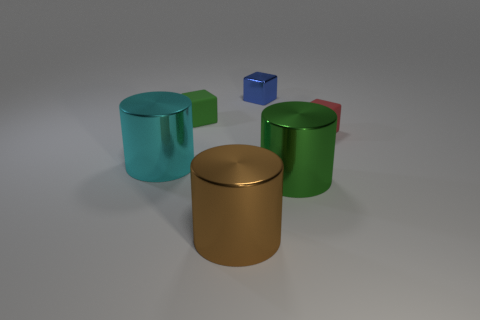Add 2 small matte objects. How many objects exist? 8 Add 4 green metal things. How many green metal things are left? 5 Add 2 big cyan matte balls. How many big cyan matte balls exist? 2 Subtract 1 cyan cylinders. How many objects are left? 5 Subtract all large cyan cylinders. Subtract all blue metal things. How many objects are left? 4 